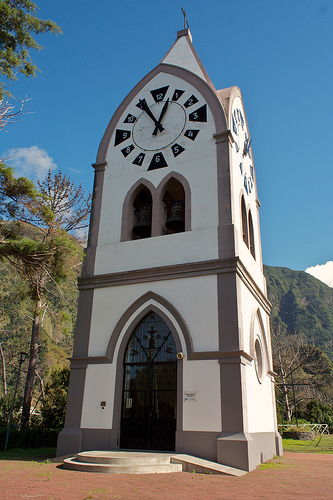Describe the environment surrounding the clock tower. The environment around the clock tower includes lush green hills, a clear blue sky, and some trees. The foreground is paved with a red-brick pathway leading to the tower's entrance. What might you hear if you were standing near the clock tower? If you were standing near the clock tower, you might hear the chimes of the bell, perhaps birds singing in the nearby trees, and the rustling of leaves in the gentle breeze. 